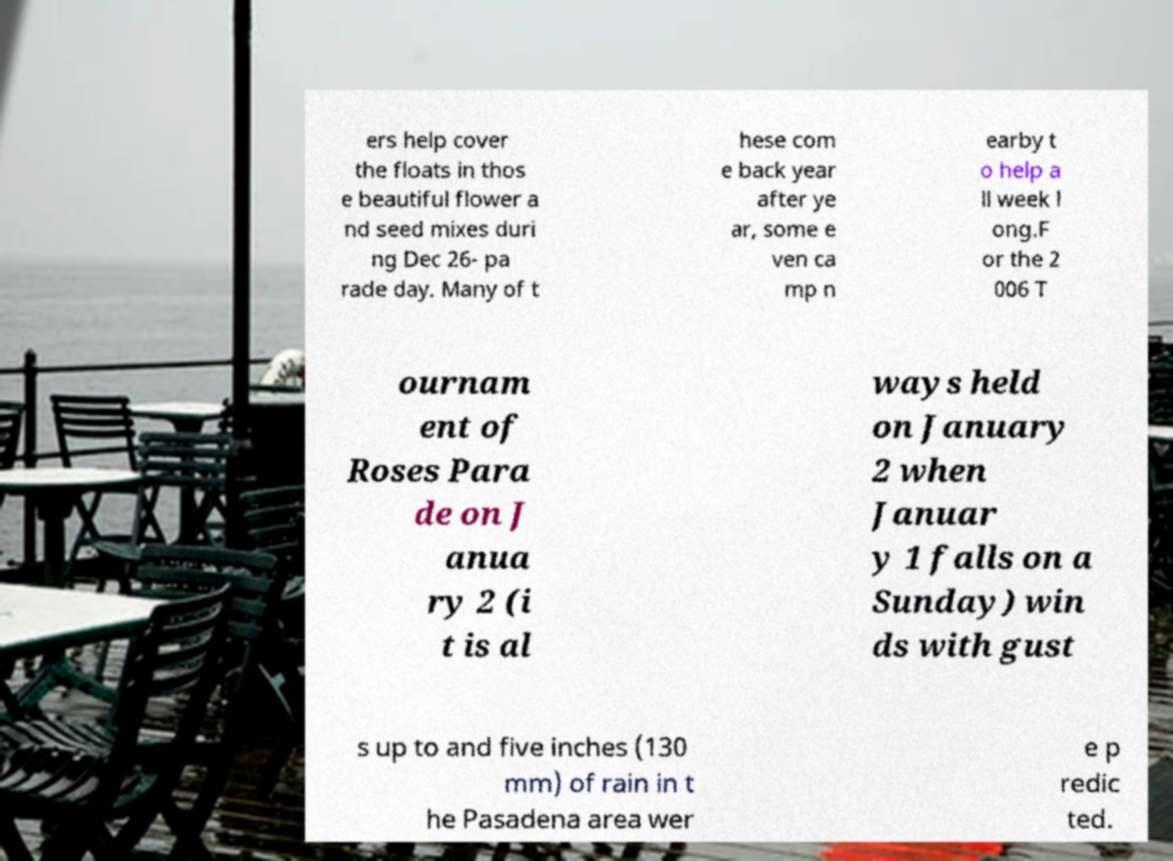Please read and relay the text visible in this image. What does it say? ers help cover the floats in thos e beautiful flower a nd seed mixes duri ng Dec 26- pa rade day. Many of t hese com e back year after ye ar, some e ven ca mp n earby t o help a ll week l ong.F or the 2 006 T ournam ent of Roses Para de on J anua ry 2 (i t is al ways held on January 2 when Januar y 1 falls on a Sunday) win ds with gust s up to and five inches (130 mm) of rain in t he Pasadena area wer e p redic ted. 